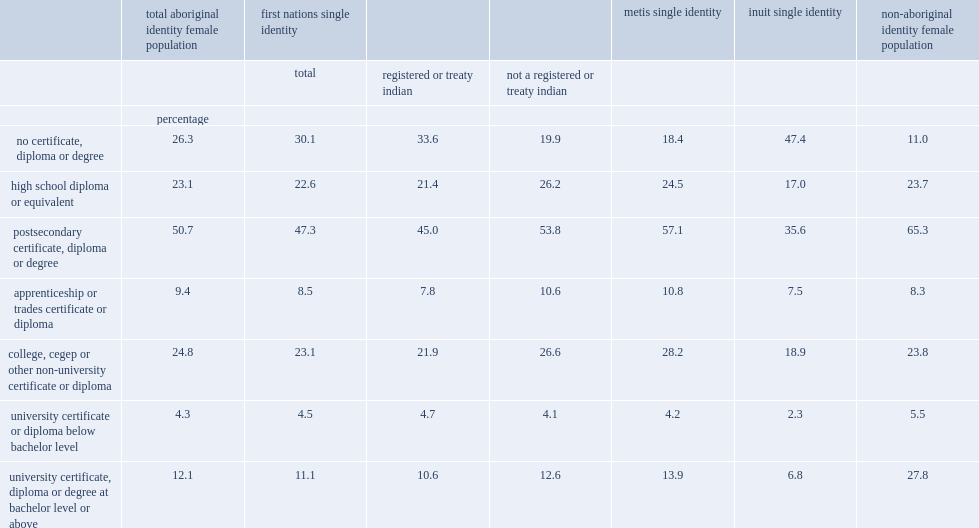In 2011, what was the percent of aboriginal women aged 25 to 64 having a postsecondary qualification? 50.7. In 2011, how many percentages of aboriginal women aged 25 to 64 had a trades certificate? 9.4. In 2011, how many percentages of aboriginal women aged 25 to 64 had a college diploma? 24.8. In 2011, how many percentages of aboriginal women aged 25 to 64 had a university certificate or diploma below the bachelor level? 4.3. In 2011, how many percentages of aboriginal women aged 25 to 64 had a university degree? 12.1. In 2011, what was the percent of non-aboriginal women aged 25 to 64 having a postsecondary qualification? 65.3. In 2011, how many percentages of non-aboriginal women aged 25 to 64 had a trades certificate? 8.3. In 2011, how many percentages of non-aboriginal women aged 25 to 64 had a college diploma? 23.8. In 2011, how many percentages of non-aboriginal women aged 25 to 64 had a university certificate or diploma below the bachelor level? 5.5. In 2011, how many percentages of non-aboriginal women aged 25 to 64 had a university degree? 27.8. Can you give me this table as a dict? {'header': ['', 'total aboriginal identity female population', 'first nations single identity', '', '', 'metis single identity', 'inuit single identity', 'non-aboriginal identity female population'], 'rows': [['', '', 'total', 'registered or treaty indian', 'not a registered or treaty indian', '', '', ''], ['', 'percentage', '', '', '', '', '', ''], ['no certificate, diploma or degree', '26.3', '30.1', '33.6', '19.9', '18.4', '47.4', '11.0'], ['high school diploma or equivalent', '23.1', '22.6', '21.4', '26.2', '24.5', '17.0', '23.7'], ['postsecondary certificate, diploma or degree', '50.7', '47.3', '45.0', '53.8', '57.1', '35.6', '65.3'], ['apprenticeship or trades certificate or diploma', '9.4', '8.5', '7.8', '10.6', '10.8', '7.5', '8.3'], ['college, cegep or other non-university certificate or diploma', '24.8', '23.1', '21.9', '26.6', '28.2', '18.9', '23.8'], ['university certificate or diploma below bachelor level', '4.3', '4.5', '4.7', '4.1', '4.2', '2.3', '5.5'], ['university certificate, diploma or degree at bachelor level or above', '12.1', '11.1', '10.6', '12.6', '13.9', '6.8', '27.8']]} 